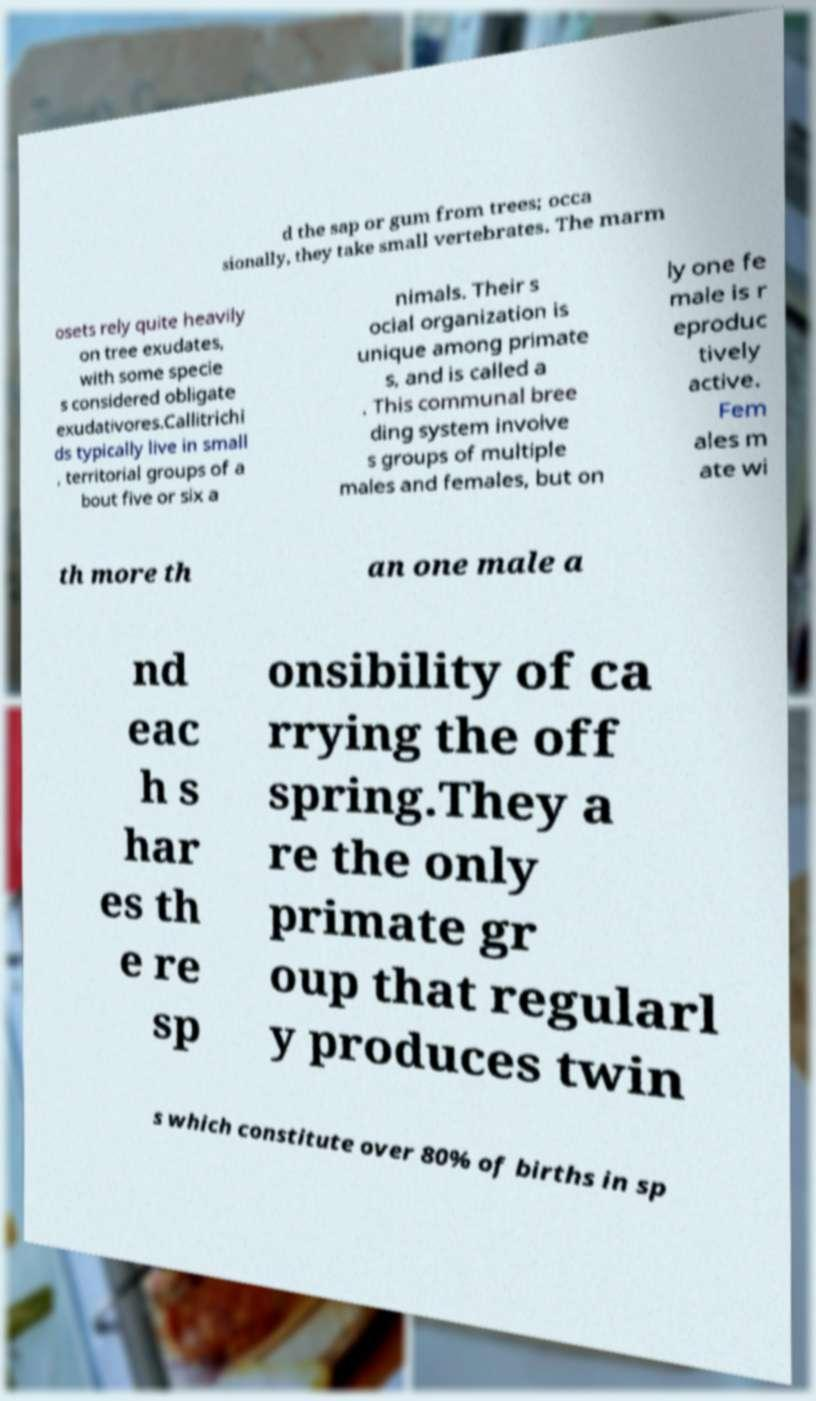Could you extract and type out the text from this image? d the sap or gum from trees; occa sionally, they take small vertebrates. The marm osets rely quite heavily on tree exudates, with some specie s considered obligate exudativores.Callitrichi ds typically live in small , territorial groups of a bout five or six a nimals. Their s ocial organization is unique among primate s, and is called a . This communal bree ding system involve s groups of multiple males and females, but on ly one fe male is r eproduc tively active. Fem ales m ate wi th more th an one male a nd eac h s har es th e re sp onsibility of ca rrying the off spring.They a re the only primate gr oup that regularl y produces twin s which constitute over 80% of births in sp 